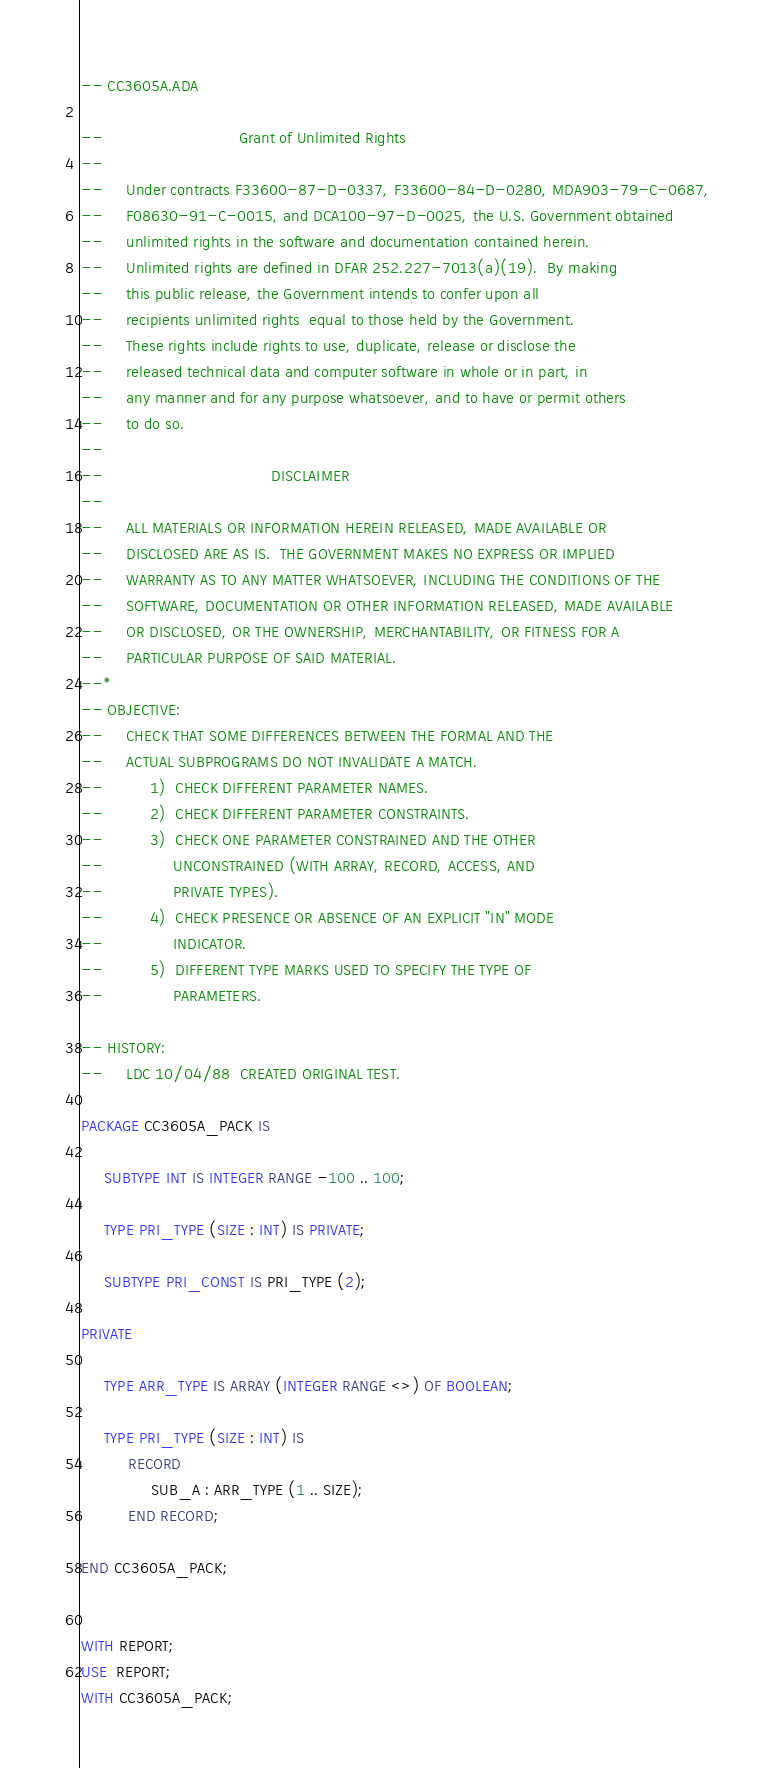Convert code to text. <code><loc_0><loc_0><loc_500><loc_500><_Ada_>-- CC3605A.ADA

--                             Grant of Unlimited Rights
--
--     Under contracts F33600-87-D-0337, F33600-84-D-0280, MDA903-79-C-0687,
--     F08630-91-C-0015, and DCA100-97-D-0025, the U.S. Government obtained 
--     unlimited rights in the software and documentation contained herein.
--     Unlimited rights are defined in DFAR 252.227-7013(a)(19).  By making 
--     this public release, the Government intends to confer upon all 
--     recipients unlimited rights  equal to those held by the Government.  
--     These rights include rights to use, duplicate, release or disclose the 
--     released technical data and computer software in whole or in part, in 
--     any manner and for any purpose whatsoever, and to have or permit others 
--     to do so.
--
--                                    DISCLAIMER
--
--     ALL MATERIALS OR INFORMATION HEREIN RELEASED, MADE AVAILABLE OR
--     DISCLOSED ARE AS IS.  THE GOVERNMENT MAKES NO EXPRESS OR IMPLIED 
--     WARRANTY AS TO ANY MATTER WHATSOEVER, INCLUDING THE CONDITIONS OF THE
--     SOFTWARE, DOCUMENTATION OR OTHER INFORMATION RELEASED, MADE AVAILABLE 
--     OR DISCLOSED, OR THE OWNERSHIP, MERCHANTABILITY, OR FITNESS FOR A
--     PARTICULAR PURPOSE OF SAID MATERIAL.
--*
-- OBJECTIVE:
--     CHECK THAT SOME DIFFERENCES BETWEEN THE FORMAL AND THE
--     ACTUAL SUBPROGRAMS DO NOT INVALIDATE A MATCH.
--          1)  CHECK DIFFERENT PARAMETER NAMES.
--          2)  CHECK DIFFERENT PARAMETER CONSTRAINTS.
--          3)  CHECK ONE PARAMETER CONSTRAINED AND THE OTHER
--               UNCONSTRAINED (WITH ARRAY, RECORD, ACCESS, AND
--               PRIVATE TYPES).
--          4)  CHECK PRESENCE OR ABSENCE OF AN EXPLICIT "IN" MODE
--               INDICATOR.
--          5)  DIFFERENT TYPE MARKS USED TO SPECIFY THE TYPE OF
--               PARAMETERS.

-- HISTORY:
--     LDC 10/04/88  CREATED ORIGINAL TEST.

PACKAGE CC3605A_PACK IS

     SUBTYPE INT IS INTEGER RANGE -100 .. 100;

     TYPE PRI_TYPE (SIZE : INT) IS PRIVATE;

     SUBTYPE PRI_CONST IS PRI_TYPE (2);

PRIVATE

     TYPE ARR_TYPE IS ARRAY (INTEGER RANGE <>) OF BOOLEAN;

     TYPE PRI_TYPE (SIZE : INT) IS
          RECORD
               SUB_A : ARR_TYPE (1 .. SIZE);
          END RECORD;

END CC3605A_PACK;


WITH REPORT;
USE  REPORT;
WITH CC3605A_PACK;</code> 